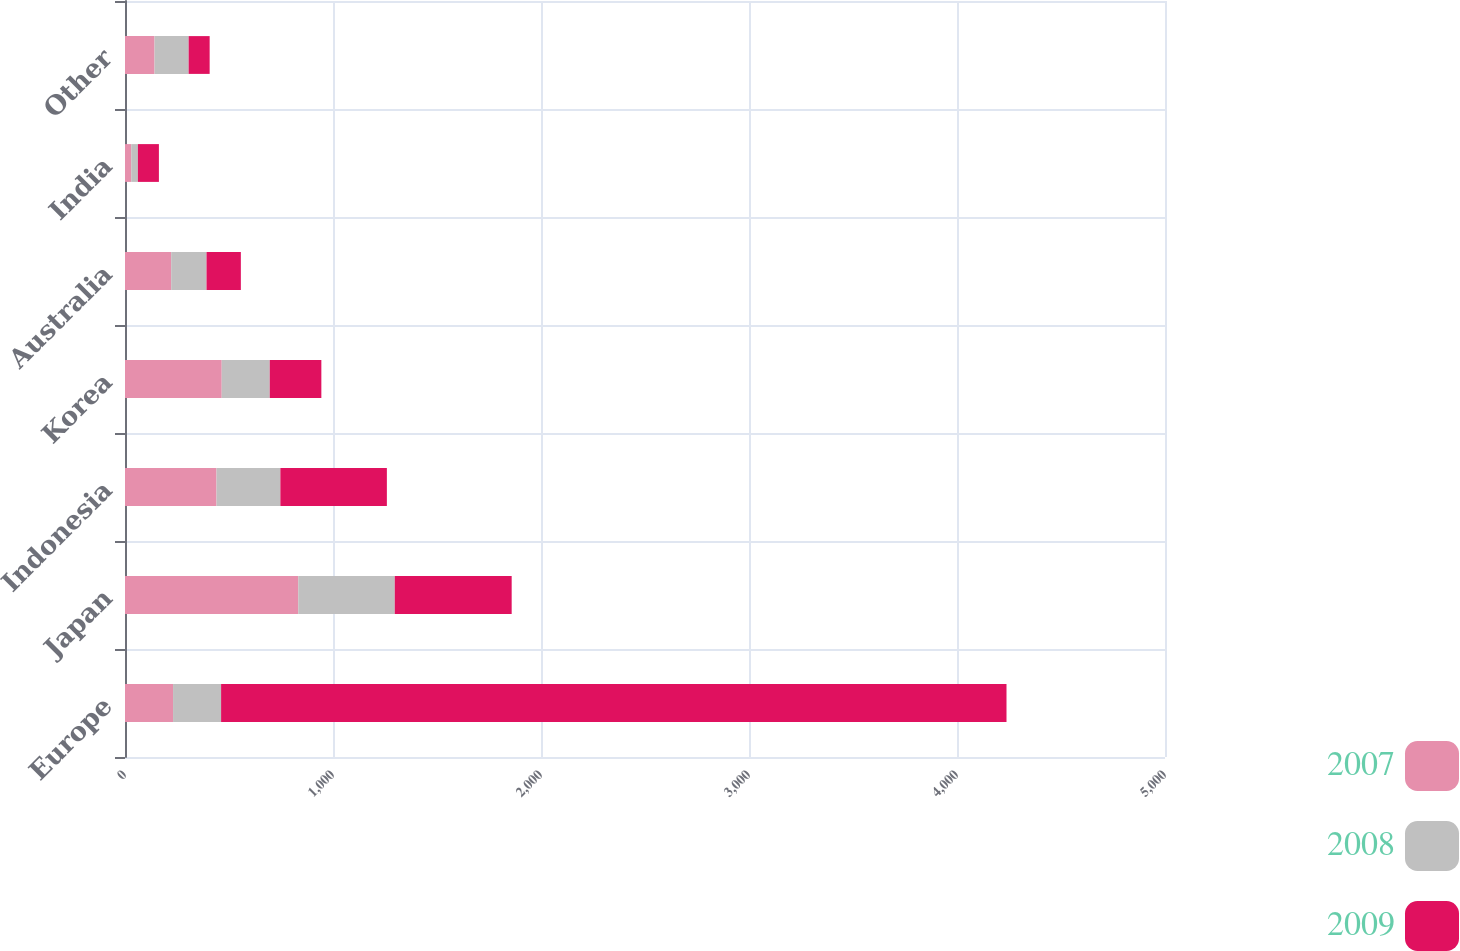Convert chart to OTSL. <chart><loc_0><loc_0><loc_500><loc_500><stacked_bar_chart><ecel><fcel>Europe<fcel>Japan<fcel>Indonesia<fcel>Korea<fcel>Australia<fcel>India<fcel>Other<nl><fcel>2007<fcel>231<fcel>833<fcel>440<fcel>465<fcel>222<fcel>30<fcel>142<nl><fcel>2008<fcel>231<fcel>464<fcel>307<fcel>231<fcel>170<fcel>32<fcel>164<nl><fcel>2009<fcel>3776<fcel>562<fcel>512<fcel>248<fcel>165<fcel>101<fcel>101<nl></chart> 